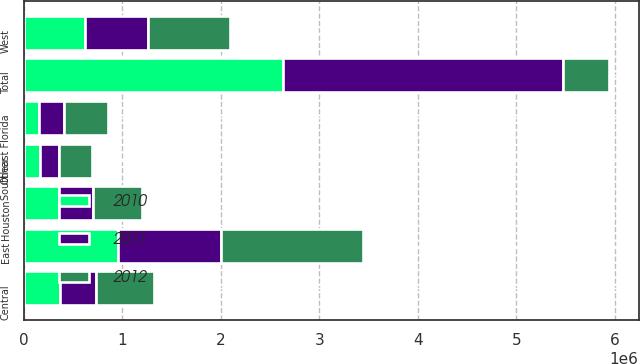Convert chart. <chart><loc_0><loc_0><loc_500><loc_500><stacked_bar_chart><ecel><fcel>East<fcel>Central<fcel>West<fcel>Southeast Florida<fcel>Houston<fcel>Other<fcel>Total<nl><fcel>2012<fcel>1.43827e+06<fcel>591677<fcel>834426<fcel>441311<fcel>505579<fcel>333232<fcel>473445<nl><fcel>2011<fcel>1.05162e+06<fcel>367274<fcel>638418<fcel>254632<fcel>342836<fcel>189658<fcel>2.84444e+06<nl><fcel>2010<fcel>954255<fcel>365667<fcel>625469<fcel>156424<fcel>355771<fcel>169025<fcel>2.62661e+06<nl></chart> 